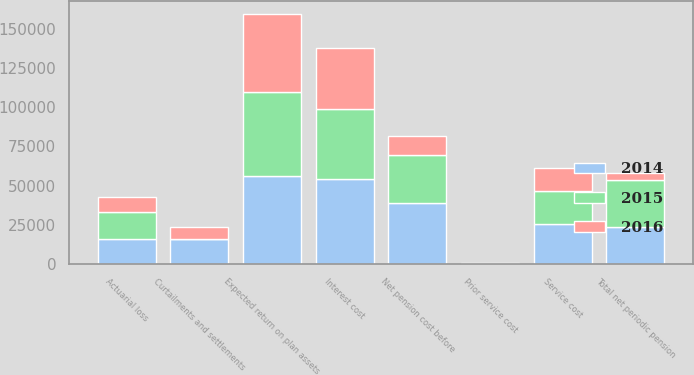Convert chart. <chart><loc_0><loc_0><loc_500><loc_500><stacked_bar_chart><ecel><fcel>Service cost<fcel>Interest cost<fcel>Expected return on plan assets<fcel>Actuarial loss<fcel>Prior service cost<fcel>Net pension cost before<fcel>Curtailments and settlements<fcel>Total net periodic pension<nl><fcel>2016<fcel>14378<fcel>38892<fcel>50190<fcel>9092<fcel>260<fcel>11912<fcel>7512<fcel>4400<nl><fcel>2015<fcel>21374<fcel>44659<fcel>53052<fcel>17398<fcel>96<fcel>30283<fcel>255<fcel>30538<nl><fcel>2014<fcel>25374<fcel>54208<fcel>56394<fcel>15993<fcel>28<fcel>39153<fcel>15894<fcel>23259<nl></chart> 